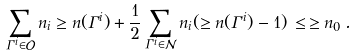Convert formula to latex. <formula><loc_0><loc_0><loc_500><loc_500>\sum _ { \Gamma ^ { i } \in \mathcal { O } } n _ { i } \geq n ( \Gamma ^ { i } ) + \frac { 1 } { 2 } \sum _ { \Gamma ^ { i } \in \mathcal { N } } n _ { i } ( \geq n ( \Gamma ^ { i } ) - 1 ) \, \leq \, \geq n _ { 0 } \, .</formula> 